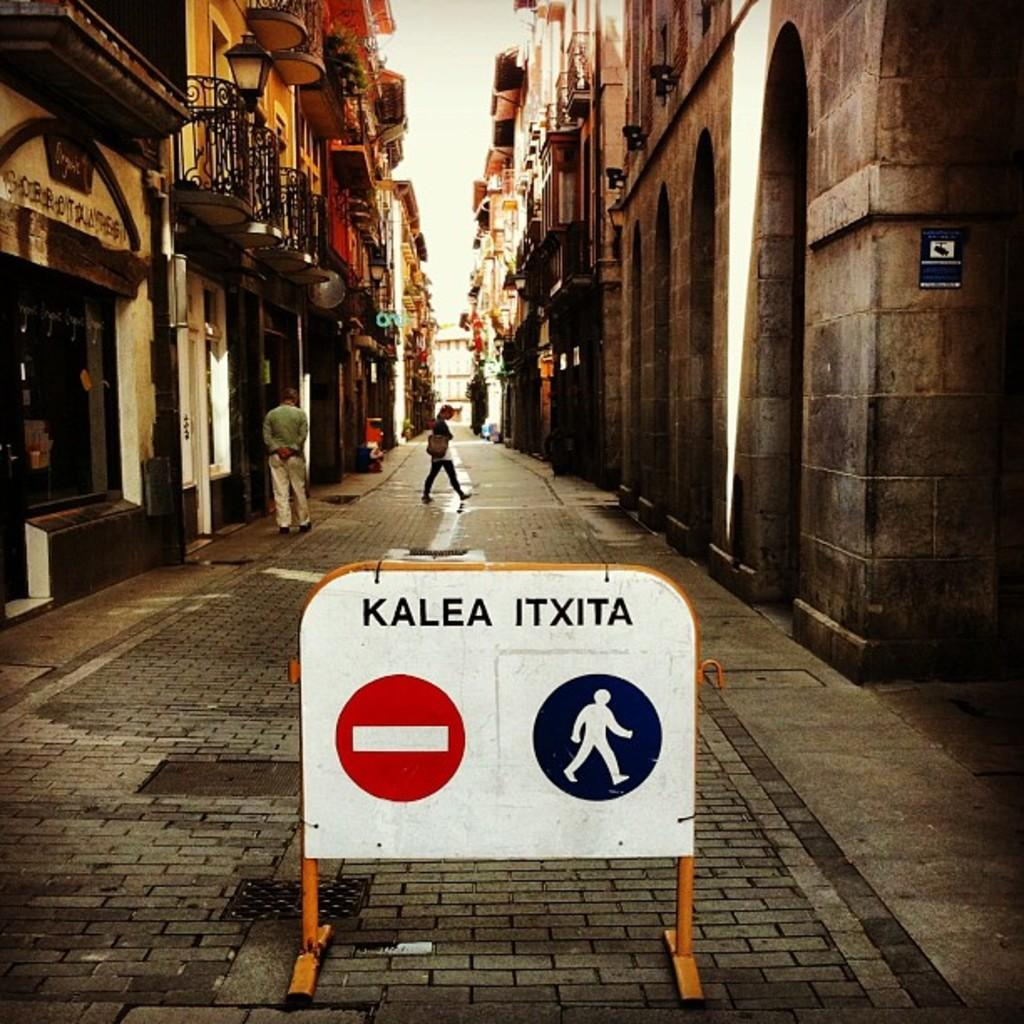<image>
Give a short and clear explanation of the subsequent image. the street has a sign in the center that says Kalea Itxita 